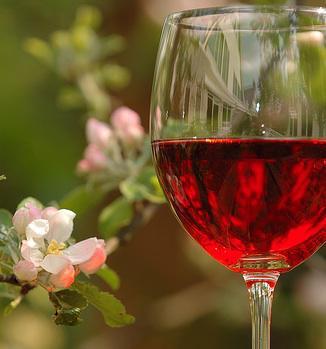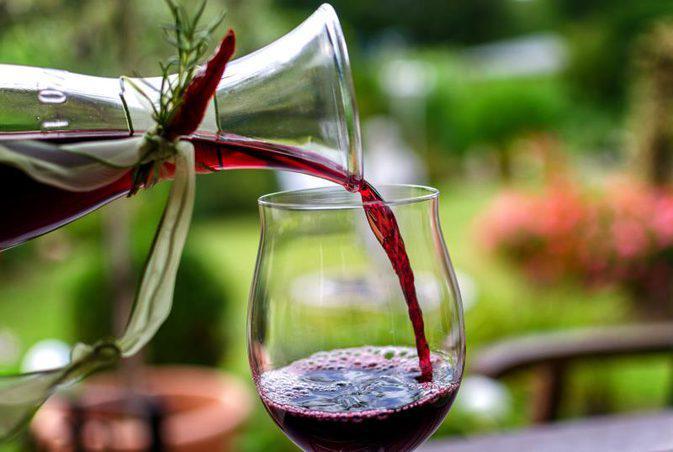The first image is the image on the left, the second image is the image on the right. Given the left and right images, does the statement "Wine is being poured in at least one image." hold true? Answer yes or no. Yes. The first image is the image on the left, the second image is the image on the right. Analyze the images presented: Is the assertion "There is a wine bottle in the iamge on the left" valid? Answer yes or no. No. 